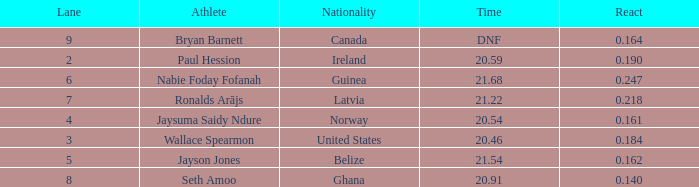Who is the athlete when react is 0.164? Bryan Barnett. Can you parse all the data within this table? {'header': ['Lane', 'Athlete', 'Nationality', 'Time', 'React'], 'rows': [['9', 'Bryan Barnett', 'Canada', 'DNF', '0.164'], ['2', 'Paul Hession', 'Ireland', '20.59', '0.190'], ['6', 'Nabie Foday Fofanah', 'Guinea', '21.68', '0.247'], ['7', 'Ronalds Arājs', 'Latvia', '21.22', '0.218'], ['4', 'Jaysuma Saidy Ndure', 'Norway', '20.54', '0.161'], ['3', 'Wallace Spearmon', 'United States', '20.46', '0.184'], ['5', 'Jayson Jones', 'Belize', '21.54', '0.162'], ['8', 'Seth Amoo', 'Ghana', '20.91', '0.140']]} 